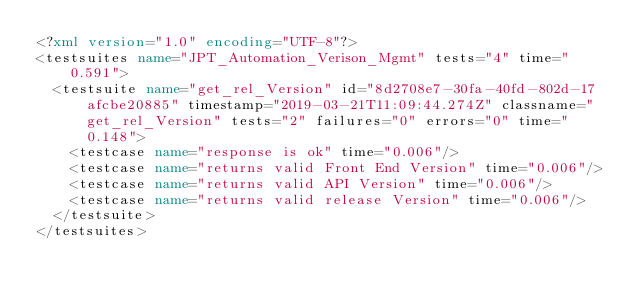Convert code to text. <code><loc_0><loc_0><loc_500><loc_500><_XML_><?xml version="1.0" encoding="UTF-8"?>
<testsuites name="JPT_Automation_Verison_Mgmt" tests="4" time="0.591">
  <testsuite name="get_rel_Version" id="8d2708e7-30fa-40fd-802d-17afcbe20885" timestamp="2019-03-21T11:09:44.274Z" classname="get_rel_Version" tests="2" failures="0" errors="0" time="0.148">
    <testcase name="response is ok" time="0.006"/>
    <testcase name="returns valid Front End Version" time="0.006"/>
    <testcase name="returns valid API Version" time="0.006"/>
    <testcase name="returns valid release Version" time="0.006"/>
  </testsuite>
</testsuites></code> 